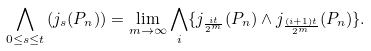Convert formula to latex. <formula><loc_0><loc_0><loc_500><loc_500>\bigwedge _ { 0 \leq s \leq t } \left ( j _ { s } ( P _ { n } ) \right ) = \lim _ { m \rightarrow \infty } \bigwedge _ { i } \{ j _ { \frac { i t } { 2 ^ { m } } } ( P _ { n } ) \wedge j _ { \frac { ( i + 1 ) t } { 2 ^ { m } } } ( P _ { n } ) \} .</formula> 